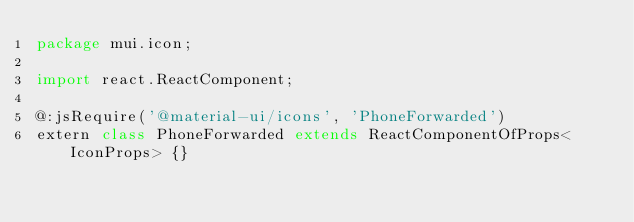Convert code to text. <code><loc_0><loc_0><loc_500><loc_500><_Haxe_>package mui.icon;

import react.ReactComponent;

@:jsRequire('@material-ui/icons', 'PhoneForwarded')
extern class PhoneForwarded extends ReactComponentOfProps<IconProps> {}
</code> 